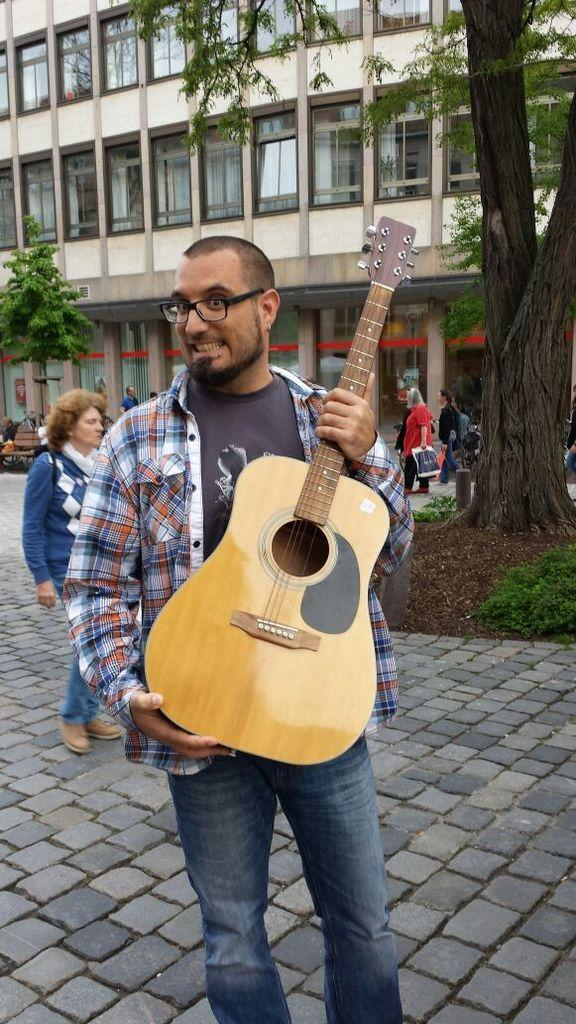How many people are in the image? There is a group of people in the image. What is the man holding in the image? The man is holding a guitar. What can be seen in the background of the image? There is a building and a tree in the background of the image. What type of stamp can be seen on the calendar in the image? There is no stamp or calendar present in the image. How many soldiers are organized in the army in the image? There is no army or soldiers present in the image. 